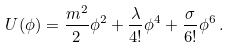Convert formula to latex. <formula><loc_0><loc_0><loc_500><loc_500>U ( \phi ) = \frac { m ^ { 2 } } { 2 } \phi ^ { 2 } + \frac { \lambda } { 4 ! } \phi ^ { 4 } + \frac { \sigma } { 6 ! } \phi ^ { 6 } \, .</formula> 